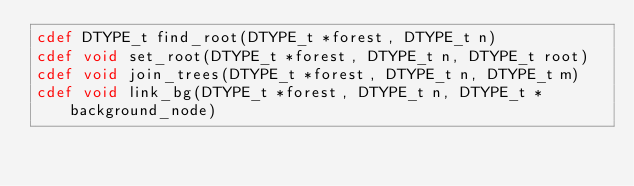Convert code to text. <code><loc_0><loc_0><loc_500><loc_500><_Cython_>cdef DTYPE_t find_root(DTYPE_t *forest, DTYPE_t n)
cdef void set_root(DTYPE_t *forest, DTYPE_t n, DTYPE_t root)
cdef void join_trees(DTYPE_t *forest, DTYPE_t n, DTYPE_t m)
cdef void link_bg(DTYPE_t *forest, DTYPE_t n, DTYPE_t *background_node)
</code> 